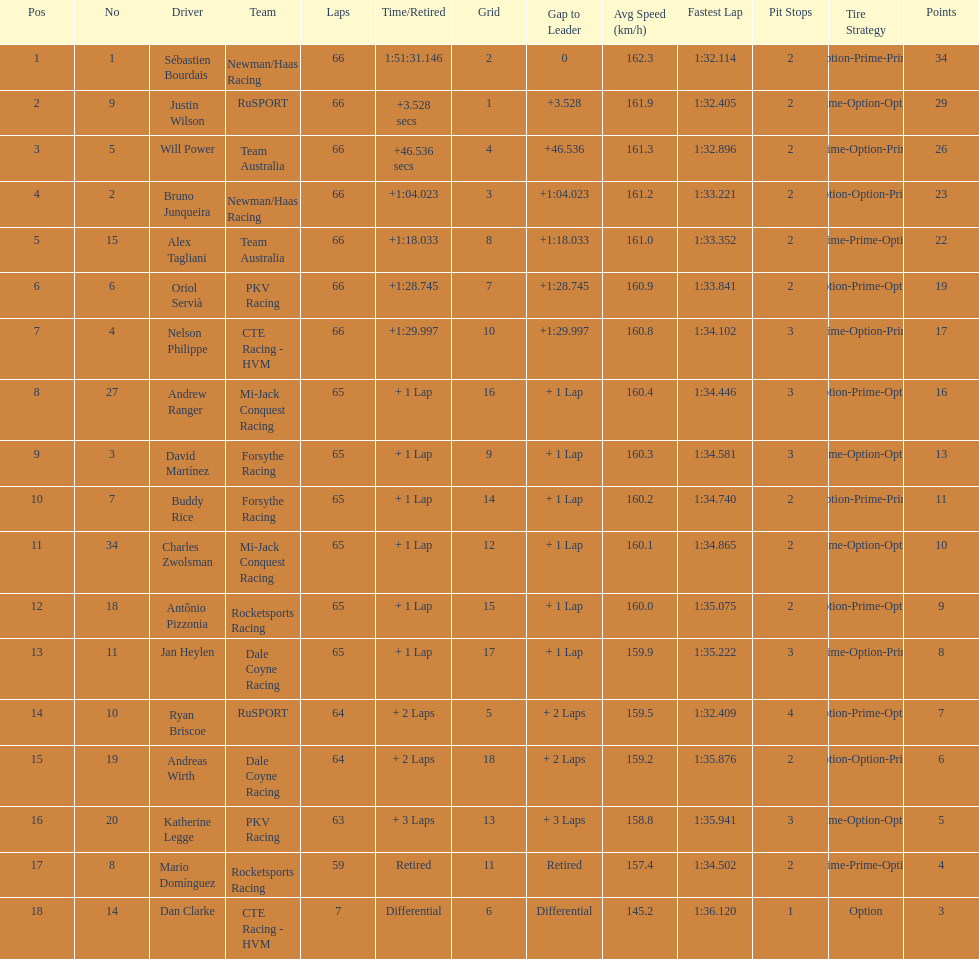745? Nelson Philippe. 